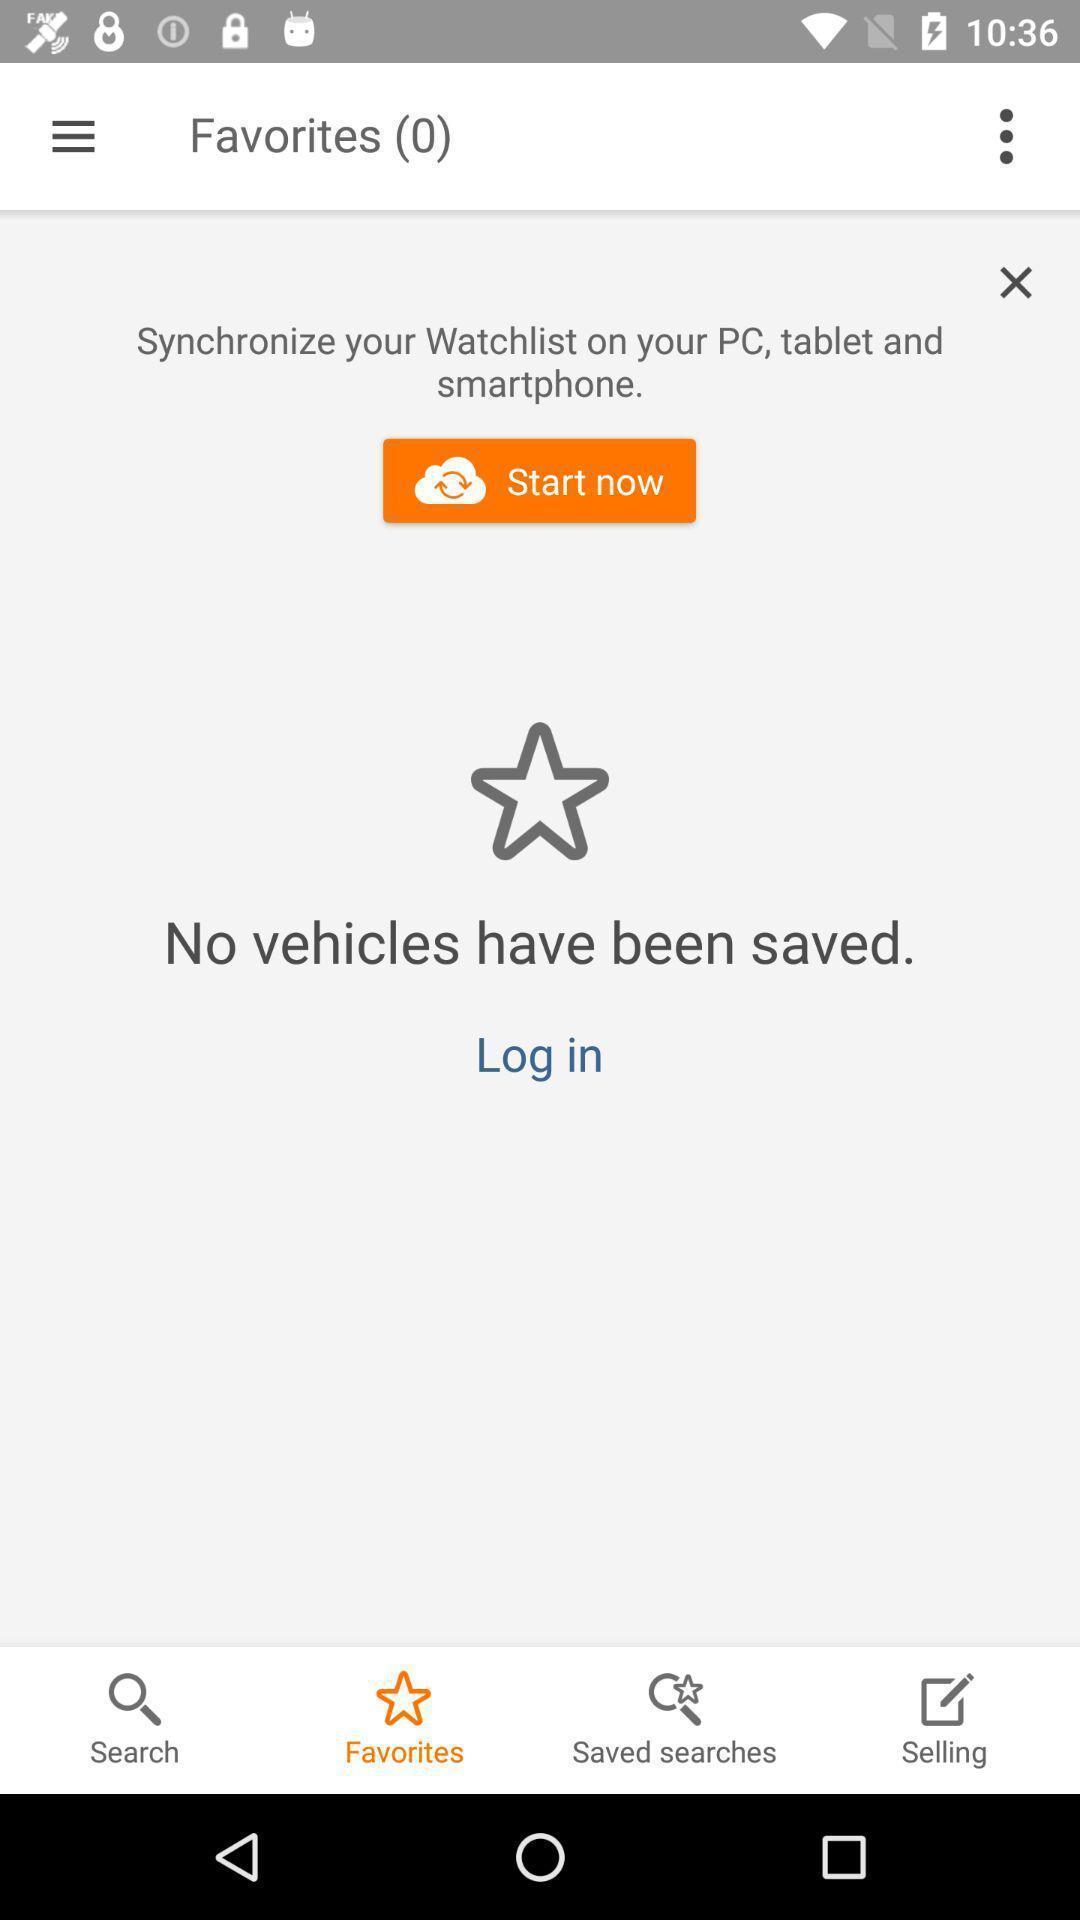Provide a description of this screenshot. Screen showing favorites page. 